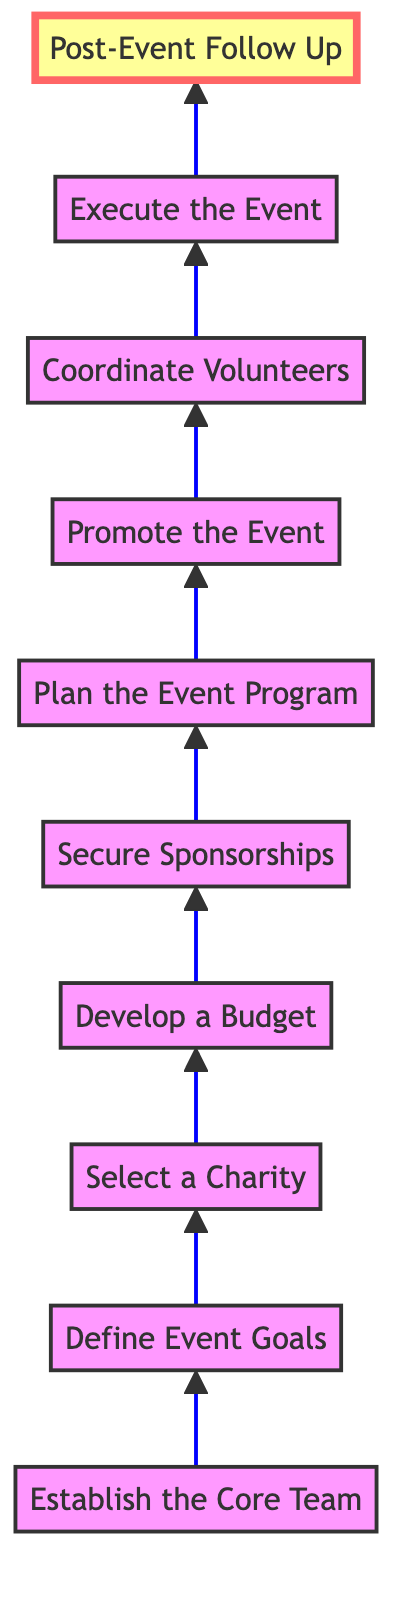What is the first step in the process? The first step in the bottom-to-top flow chart is "Establish the Core Team," meaning this is where the planning starts by gathering dedicated neighbors.
Answer: Establish the Core Team How many steps are there in total? By counting the nodes in the diagram, there are ten distinct steps from establishing the core team to post-event follow-up.
Answer: Ten What is the last action mentioned in the flow? The last action mentioned in the flow is "Post-Event Follow Up," indicating what needs to be done after the event concludes.
Answer: Post-Event Follow Up Which step comes immediately before 'Execute the Event'? The step that comes immediately before 'Execute the Event' is 'Coordinate Volunteers', as it prepares for the execution by ensuring volunteers are ready.
Answer: Coordinate Volunteers Which step focuses on defining how to raise funds? The step that focuses on defining how to raise funds is 'Develop a Budget,' as it outlines financial planning for the event, including fundraising targets.
Answer: Develop a Budget What connects 'Plan the Event Program' and 'Promote the Event'? The connection between 'Plan the Event Program' and 'Promote the Event' is a sequential process where planning leads to promotion for raising awareness about the event.
Answer: Sequential process What is the significance of securing sponsorships? Securing sponsorships is significant as it provides necessary financial or in-kind support to facilitate the charity event.
Answer: Financial support Which nodes describe activities directly related to the event execution? The nodes that describe activities directly related to the event execution are 'Plan the Event Program', 'Promote the Event', 'Coordinate Volunteers', and 'Execute the Event'.
Answer: Four nodes What is the main purpose of 'Post-Event Follow Up'? The main purpose of 'Post-Event Follow Up' is to express gratitude, share outcomes, and evaluate the event for future improvements.
Answer: Evaluation and gratitude 